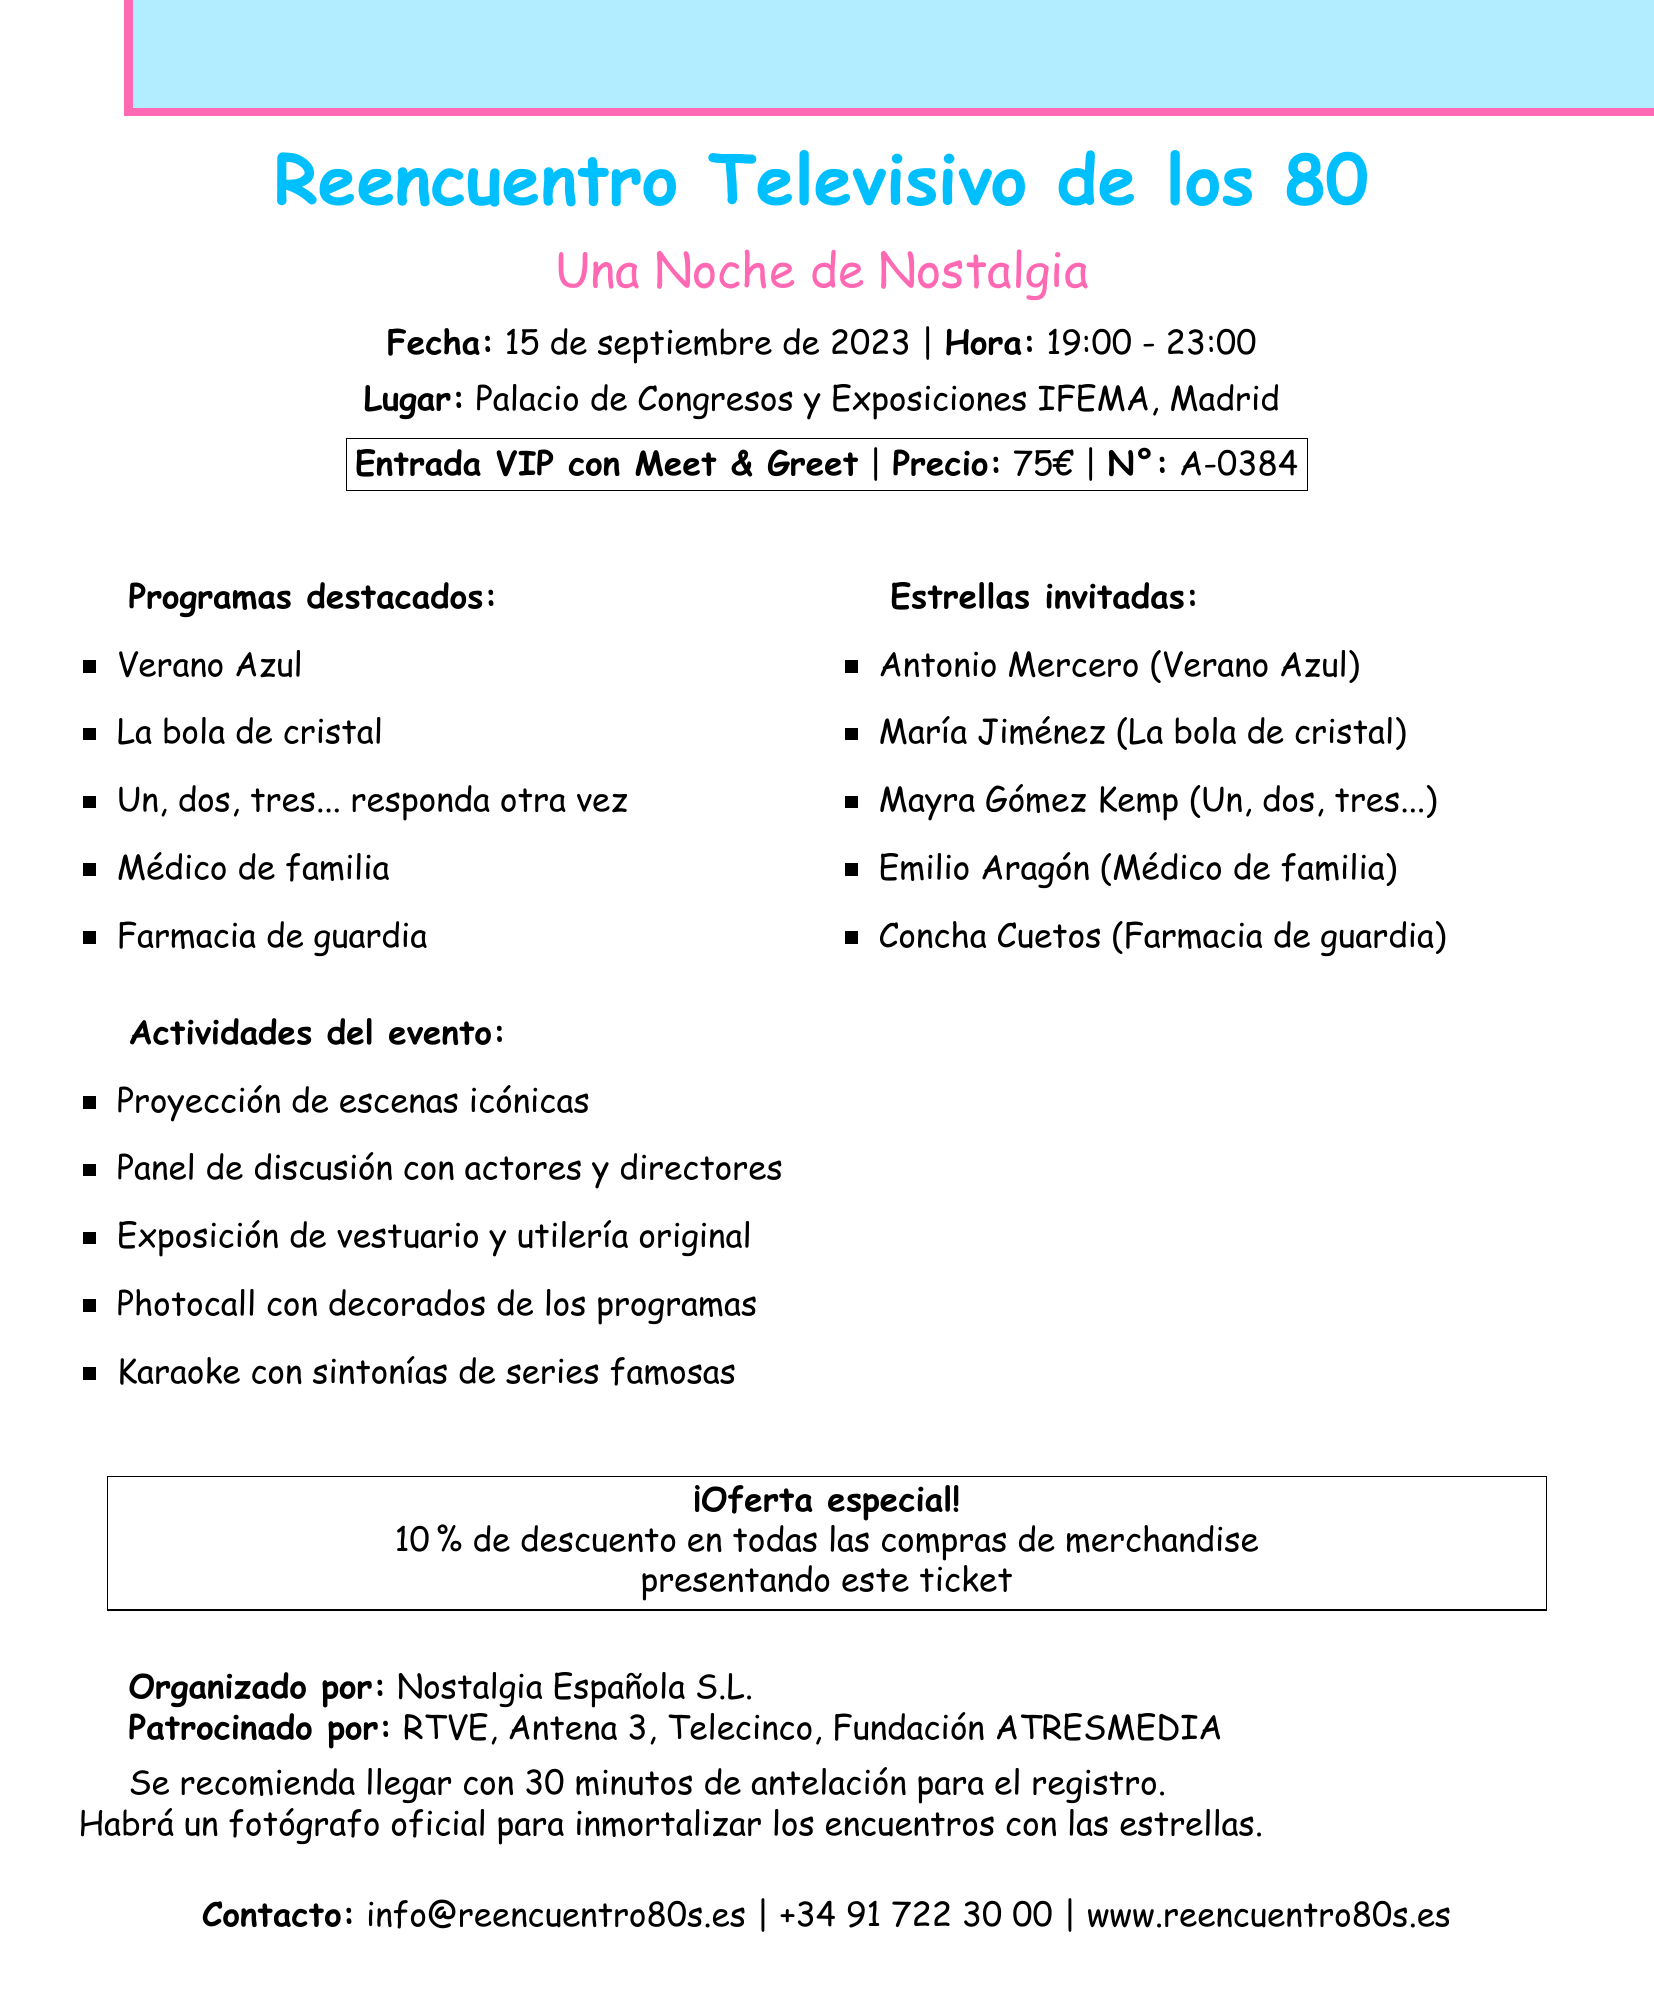What is the event date? The event date is specified in the document, which states it will take place on September 15, 2023.
Answer: 15 de septiembre de 2023 What type of ticket is offered? The document mentions the ticket type offered for the event, which is a VIP entry with a meet and greet.
Answer: Entrada VIP con Meet & Greet Who is the guest star from "Médico de familia"? The document lists guest stars and identifies Emilio Aragón as the guest star from "Médico de familia."
Answer: Emilio Aragón What is the duration of the event? The document states the event runs from 19:00 to 23:00, indicating its duration is four hours.
Answer: 4 horas What special offer is available for merchandise purchases? The document provides information about discounts offered for merchandise, mentioning a specific percentage.
Answer: Descuento del 10% Which shows are featured at the event? The document lists several shows that will be highlighted during the event.
Answer: Verano Azul, La bola de cristal, Un, dos, tres... responda otra vez, Médico de familia, Farmacia de guardia What activities are planned for the event? A section in the document details the activities planned, which includes iconic scene projections and discussions.
Answer: Proyección de escenas icónicas What is the contact email for the event? The document specifies a contact email for further inquiries about the event.
Answer: info@reencuentro80s.es 